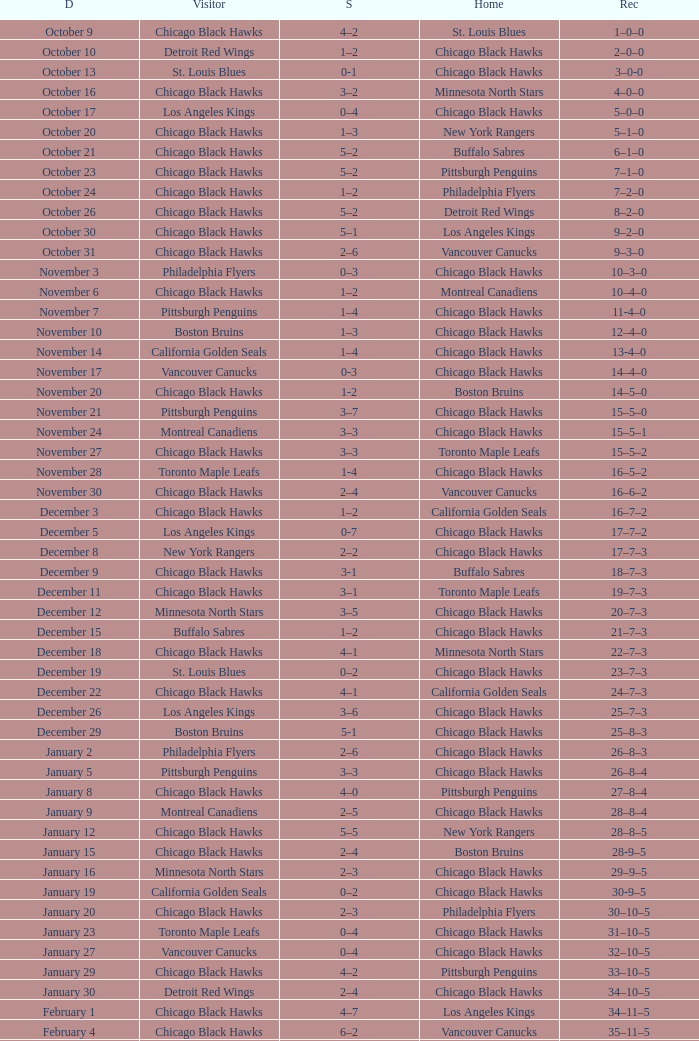What is the Record from February 10? 36–13–5. 